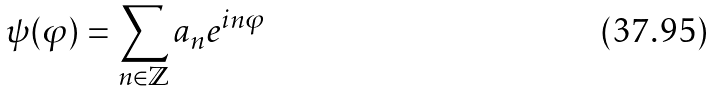<formula> <loc_0><loc_0><loc_500><loc_500>\psi ( \varphi ) = \sum _ { n \in \mathbb { Z } } a _ { n } e ^ { i n \varphi }</formula> 